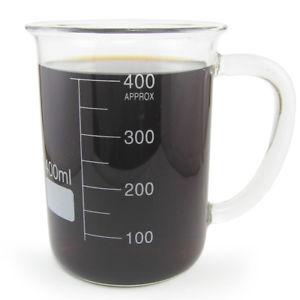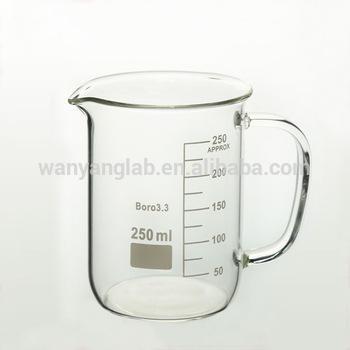The first image is the image on the left, the second image is the image on the right. Assess this claim about the two images: "The container in each of the images is filled with dark liquid.". Correct or not? Answer yes or no. No. The first image is the image on the left, the second image is the image on the right. Assess this claim about the two images: "Both beakers are full of coffee.". Correct or not? Answer yes or no. No. 